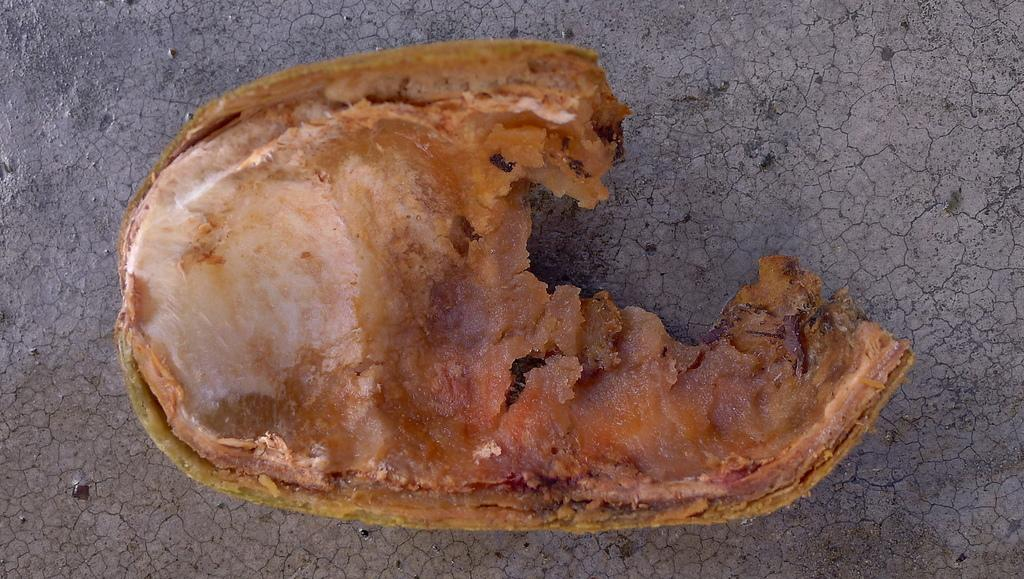What is the main subject of the image? There is a food item in the center of the image. Can you describe the appearance of the food item? The food item is brown in color. What type of sofa can be seen in the aftermath of the food item in the image? There is no sofa or any reference to an aftermath in the image; it only features a brown food item. 